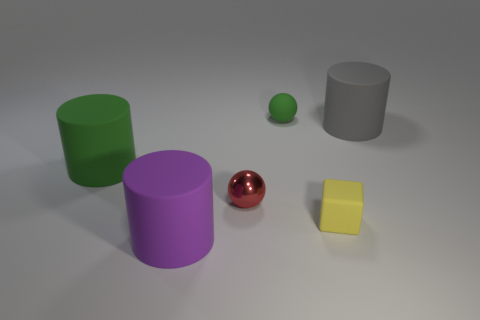Add 1 small green objects. How many objects exist? 7 Subtract all purple cylinders. How many cylinders are left? 2 Subtract 0 gray blocks. How many objects are left? 6 Subtract all cubes. How many objects are left? 5 Subtract 1 cubes. How many cubes are left? 0 Subtract all blue spheres. Subtract all yellow cylinders. How many spheres are left? 2 Subtract all cyan cylinders. How many red balls are left? 1 Subtract all yellow objects. Subtract all large green rubber cylinders. How many objects are left? 4 Add 3 red metallic objects. How many red metallic objects are left? 4 Add 2 big gray matte cylinders. How many big gray matte cylinders exist? 3 